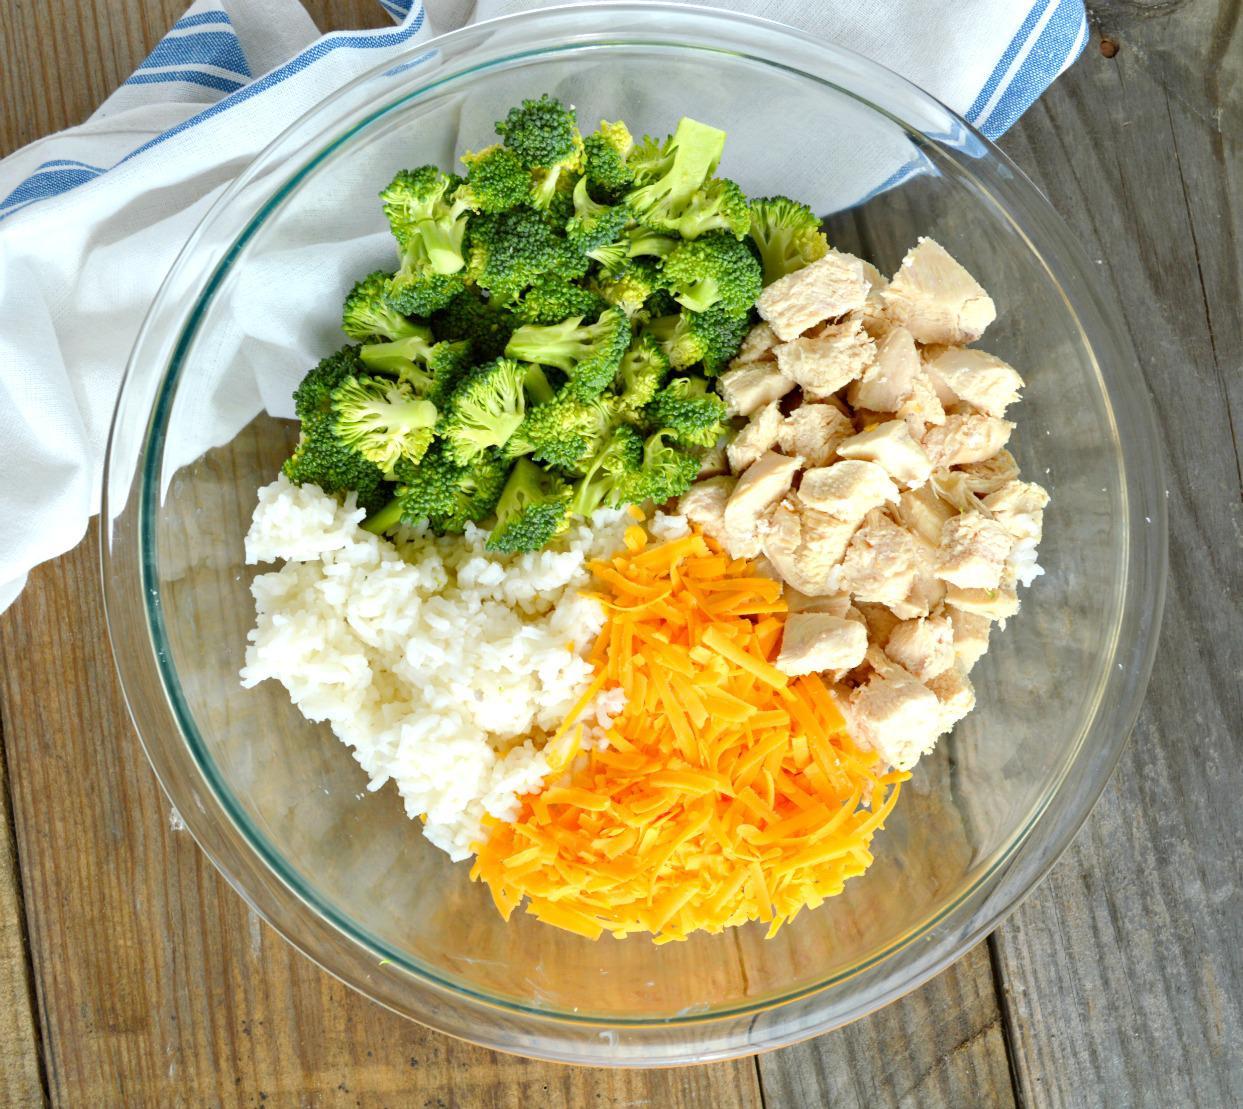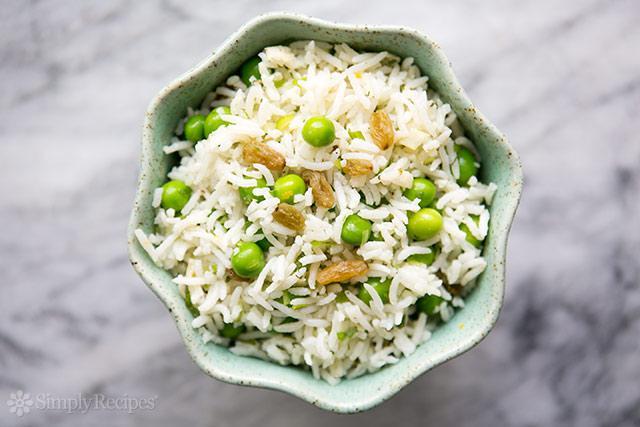The first image is the image on the left, the second image is the image on the right. For the images shown, is this caption "In one of the images there is a broccoli casserole with a large serving spoon in it." true? Answer yes or no. No. 